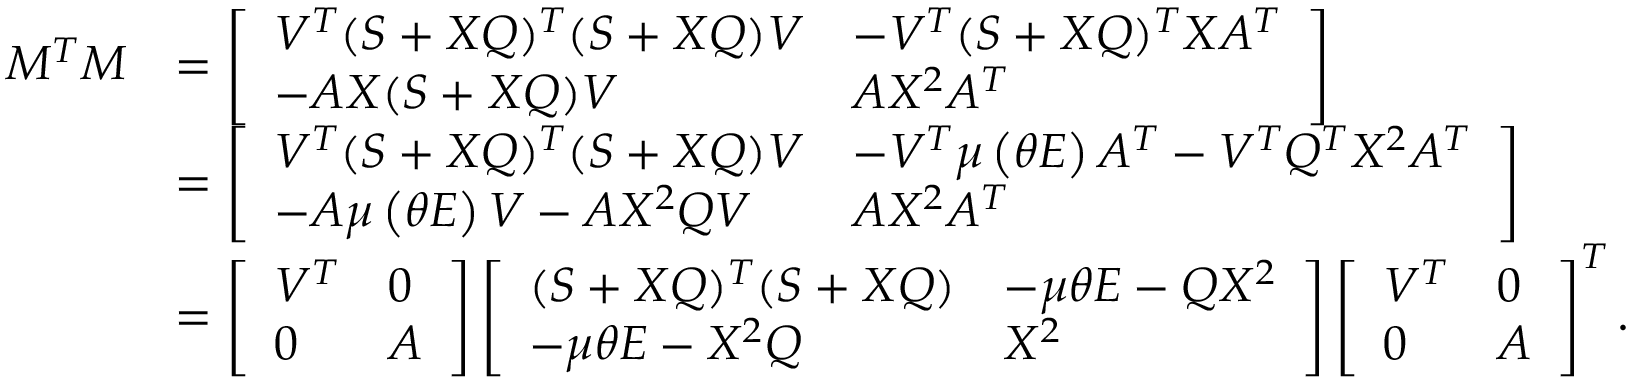Convert formula to latex. <formula><loc_0><loc_0><loc_500><loc_500>\begin{array} { r l } { M ^ { T } M } & { = \left [ \begin{array} { l l } { V ^ { T } ( S + X Q ) ^ { T } ( S + X Q ) V } & { - V ^ { T } ( S + X Q ) ^ { T } X A ^ { T } } \\ { - A X ( S + X Q ) V } & { A X ^ { 2 } A ^ { T } } \end{array} \right ] } \\ & { = \left [ \begin{array} { l l } { V ^ { T } ( S + X Q ) ^ { T } ( S + X Q ) V } & { - V ^ { T } \mu \left ( \theta E \right ) A ^ { T } - V ^ { T } Q ^ { T } X ^ { 2 } A ^ { T } } \\ { - A \mu \left ( \theta E \right ) V - A X ^ { 2 } Q V } & { A X ^ { 2 } A ^ { T } } \end{array} \right ] } \\ & { = \left [ \begin{array} { l l } { V ^ { T } } & { 0 } \\ { 0 } & { A } \end{array} \right ] \left [ \begin{array} { l l } { ( S + X Q ) ^ { T } ( S + X Q ) } & { - \mu \theta E - Q X ^ { 2 } } \\ { - \mu \theta E - X ^ { 2 } Q } & { X ^ { 2 } } \end{array} \right ] \left [ \begin{array} { l l } { V ^ { T } } & { 0 } \\ { 0 } & { A } \end{array} \right ] ^ { T } . } \end{array}</formula> 